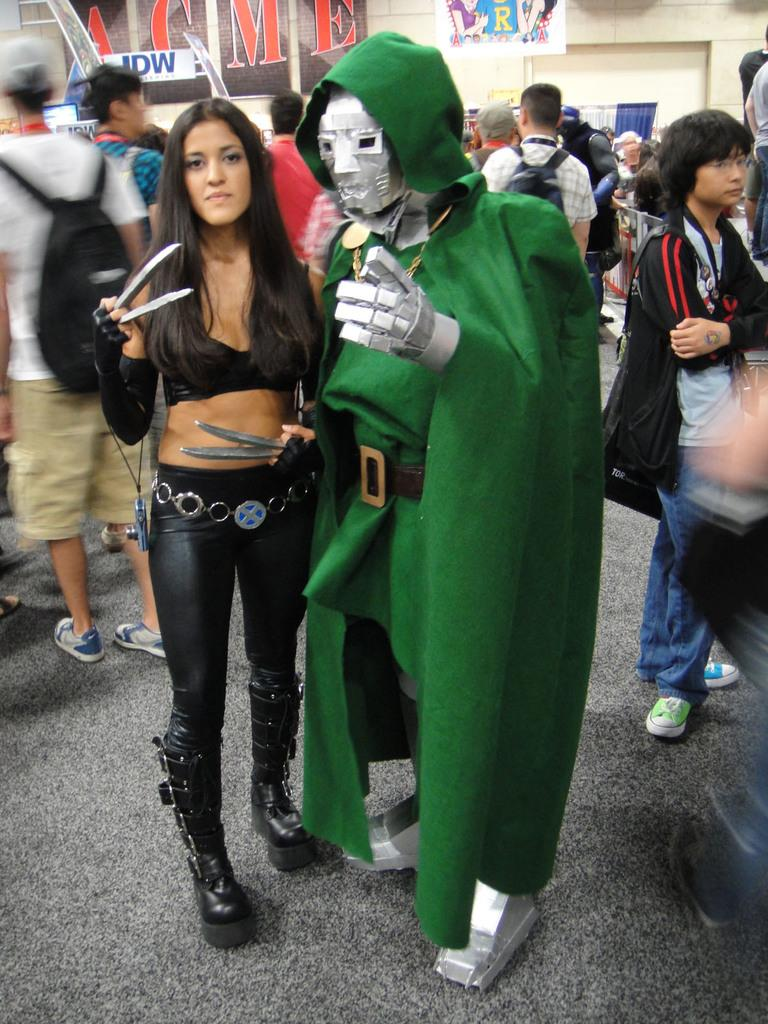What is happening in the image? There are people standing in the image. What are the people holding? The people are holding something. What can be seen in the background of the image? There is a wall visible in the background. What is on the wall in the image? There are banners on the wall. What type of chair is depicted on the banners in the image? There are no chairs depicted on the banners in the image; the banners feature unspecified designs or text. 